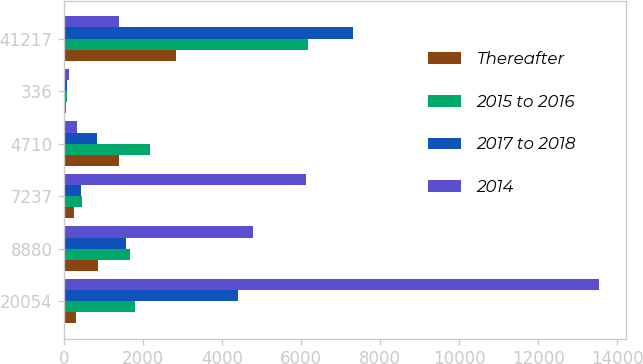Convert chart to OTSL. <chart><loc_0><loc_0><loc_500><loc_500><stacked_bar_chart><ecel><fcel>20054<fcel>8880<fcel>7237<fcel>4710<fcel>336<fcel>41217<nl><fcel>Thereafter<fcel>312<fcel>852<fcel>247<fcel>1379<fcel>45<fcel>2835<nl><fcel>2015 to 2016<fcel>1803<fcel>1668<fcel>449<fcel>2176<fcel>84<fcel>6180<nl><fcel>2017 to 2018<fcel>4400<fcel>1575<fcel>423<fcel>828<fcel>75<fcel>7301<nl><fcel>2014<fcel>13539<fcel>4785<fcel>6118<fcel>327<fcel>132<fcel>1379<nl></chart> 